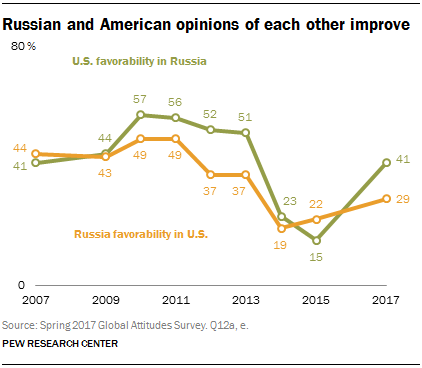Specify some key components in this picture. The overall favorability of Russia in the United States is 329. The highest value in U.S favorability in Russia was 57%. 